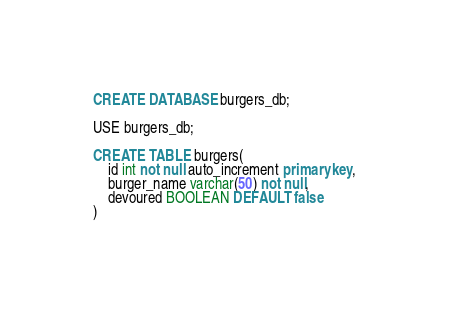Convert code to text. <code><loc_0><loc_0><loc_500><loc_500><_SQL_>CREATE DATABASE burgers_db;

USE burgers_db;

CREATE TABLE burgers(
    id int not null auto_increment primary key,
    burger_name varchar(50) not null,
    devoured BOOLEAN DEFAULT false
)</code> 